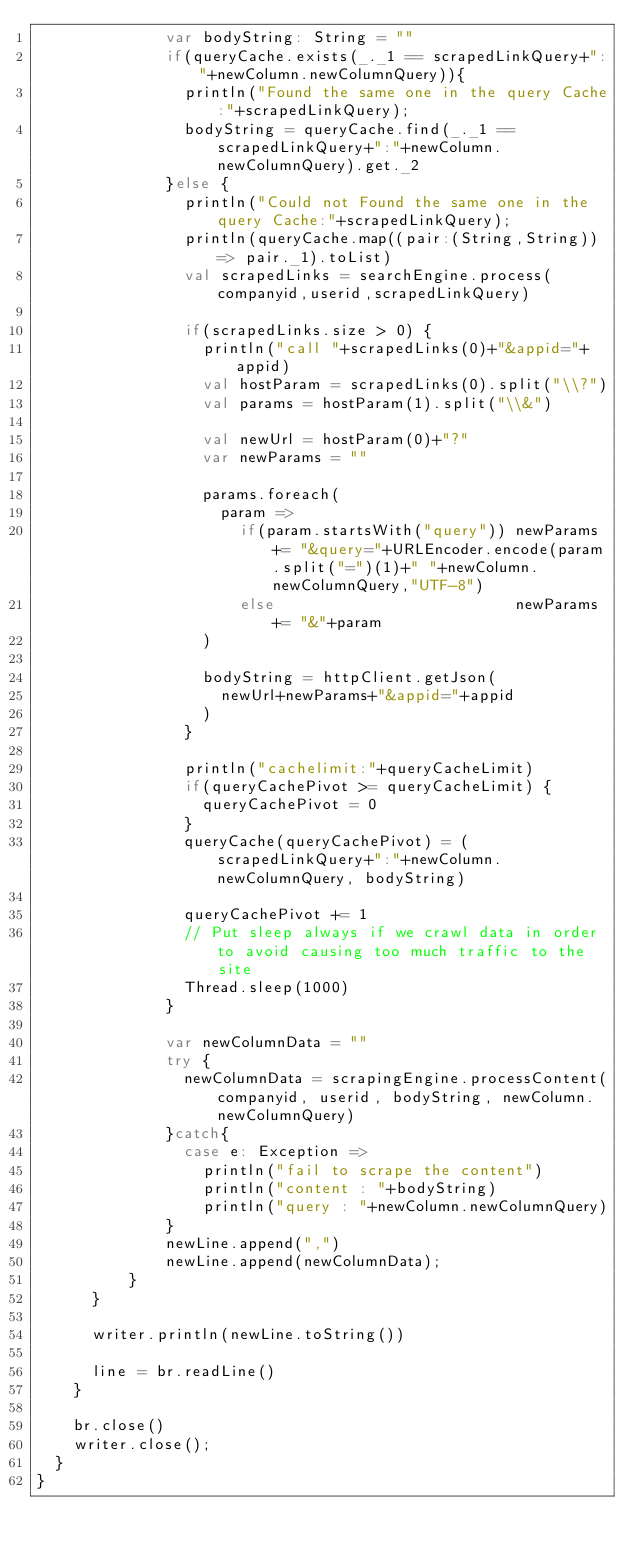Convert code to text. <code><loc_0><loc_0><loc_500><loc_500><_Scala_>              var bodyString: String = ""
              if(queryCache.exists(_._1 == scrapedLinkQuery+":"+newColumn.newColumnQuery)){
                println("Found the same one in the query Cache:"+scrapedLinkQuery);
                bodyString = queryCache.find(_._1 == scrapedLinkQuery+":"+newColumn.newColumnQuery).get._2
              }else {
                println("Could not Found the same one in the query Cache:"+scrapedLinkQuery);
                println(queryCache.map((pair:(String,String)) => pair._1).toList)
                val scrapedLinks = searchEngine.process(companyid,userid,scrapedLinkQuery)

                if(scrapedLinks.size > 0) {
                  println("call "+scrapedLinks(0)+"&appid="+appid)
                  val hostParam = scrapedLinks(0).split("\\?")
                  val params = hostParam(1).split("\\&")

                  val newUrl = hostParam(0)+"?"
                  var newParams = ""

                  params.foreach(
                    param =>
                      if(param.startsWith("query")) newParams += "&query="+URLEncoder.encode(param.split("=")(1)+" "+newColumn.newColumnQuery,"UTF-8")
                      else                          newParams += "&"+param
                  )

                  bodyString = httpClient.getJson(
                    newUrl+newParams+"&appid="+appid
                  )
                }

                println("cachelimit:"+queryCacheLimit)
                if(queryCachePivot >= queryCacheLimit) {
                  queryCachePivot = 0
                }
                queryCache(queryCachePivot) = (scrapedLinkQuery+":"+newColumn.newColumnQuery, bodyString)

                queryCachePivot += 1
                // Put sleep always if we crawl data in order to avoid causing too much traffic to the site
                Thread.sleep(1000)
              }

              var newColumnData = ""
              try {
                newColumnData = scrapingEngine.processContent(companyid, userid, bodyString, newColumn.newColumnQuery)
              }catch{
                case e: Exception =>
                  println("fail to scrape the content")
                  println("content : "+bodyString)
                  println("query : "+newColumn.newColumnQuery)
              }
              newLine.append(",")
              newLine.append(newColumnData);
          }
      }

      writer.println(newLine.toString())

      line = br.readLine()
    }

    br.close()
    writer.close();
  }
}
</code> 